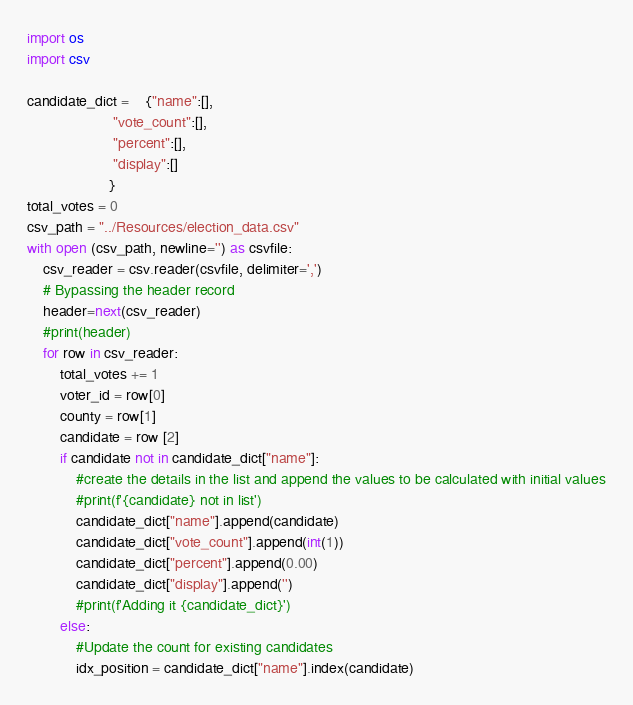Convert code to text. <code><loc_0><loc_0><loc_500><loc_500><_Python_>import os
import csv

candidate_dict =    {"name":[],
                     "vote_count":[],
                     "percent":[],
                     "display":[]
                    }
total_votes = 0
csv_path = "../Resources/election_data.csv"
with open (csv_path, newline='') as csvfile:
    csv_reader = csv.reader(csvfile, delimiter=',')
    # Bypassing the header record
    header=next(csv_reader)
    #print(header)
    for row in csv_reader:
        total_votes += 1
        voter_id = row[0]
        county = row[1]
        candidate = row [2]
        if candidate not in candidate_dict["name"]:
            #create the details in the list and append the values to be calculated with initial values
            #print(f'{candidate} not in list')
            candidate_dict["name"].append(candidate)
            candidate_dict["vote_count"].append(int(1))
            candidate_dict["percent"].append(0.00)
            candidate_dict["display"].append('')
            #print(f'Adding it {candidate_dict}')
        else:
            #Update the count for existing candidates
            idx_position = candidate_dict["name"].index(candidate)</code> 